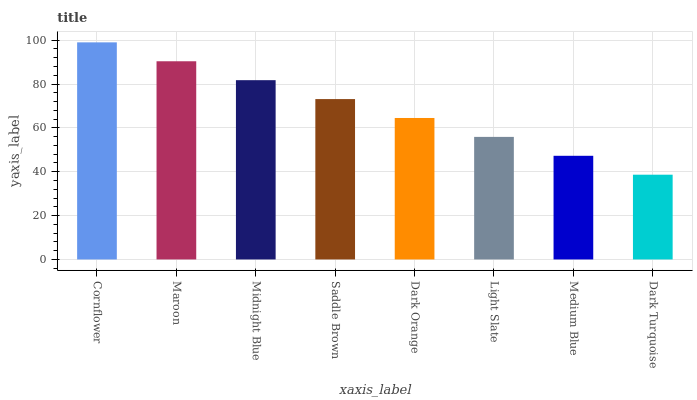Is Dark Turquoise the minimum?
Answer yes or no. Yes. Is Cornflower the maximum?
Answer yes or no. Yes. Is Maroon the minimum?
Answer yes or no. No. Is Maroon the maximum?
Answer yes or no. No. Is Cornflower greater than Maroon?
Answer yes or no. Yes. Is Maroon less than Cornflower?
Answer yes or no. Yes. Is Maroon greater than Cornflower?
Answer yes or no. No. Is Cornflower less than Maroon?
Answer yes or no. No. Is Saddle Brown the high median?
Answer yes or no. Yes. Is Dark Orange the low median?
Answer yes or no. Yes. Is Midnight Blue the high median?
Answer yes or no. No. Is Maroon the low median?
Answer yes or no. No. 